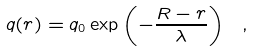Convert formula to latex. <formula><loc_0><loc_0><loc_500><loc_500>q ( r ) = q _ { 0 } \exp \left ( - \frac { R - r } { \lambda } \right ) \ ,</formula> 